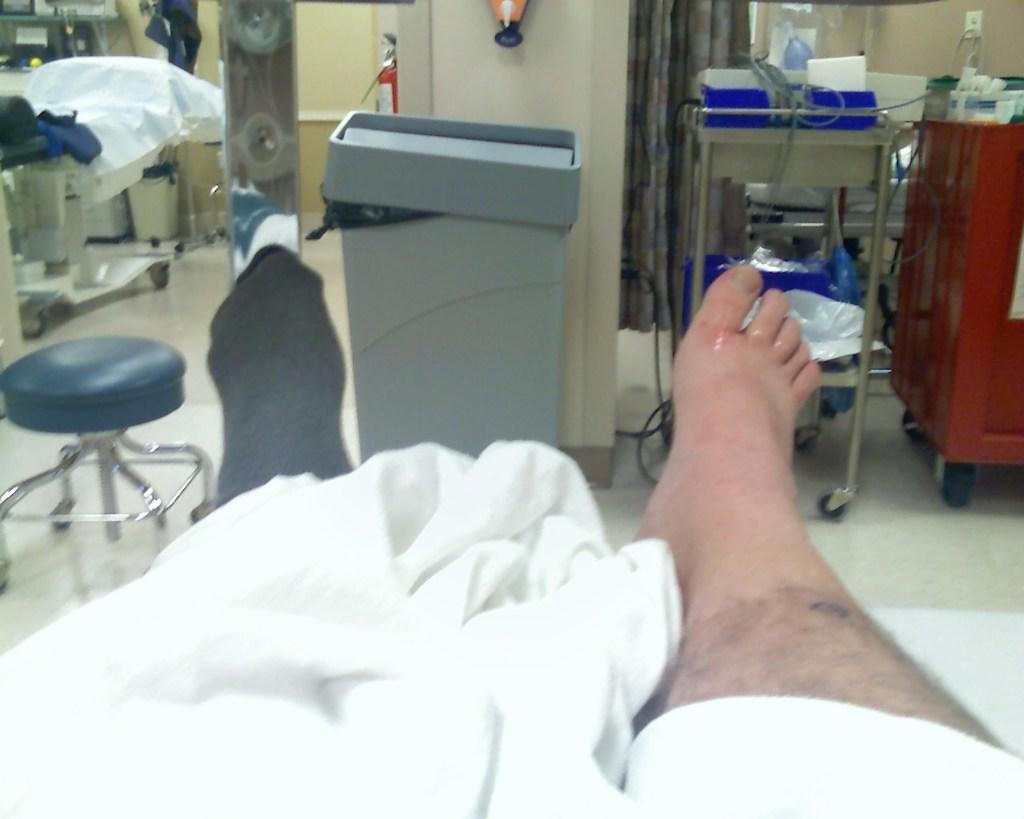Describe this image in one or two sentences. In this picture we can observe human legs on the bed. There is a white color blanket. We can observe a hospital room in which there are some medical accessories placed on this trolley. On the left side we can observe another bed. There is a fire extinguisher. 